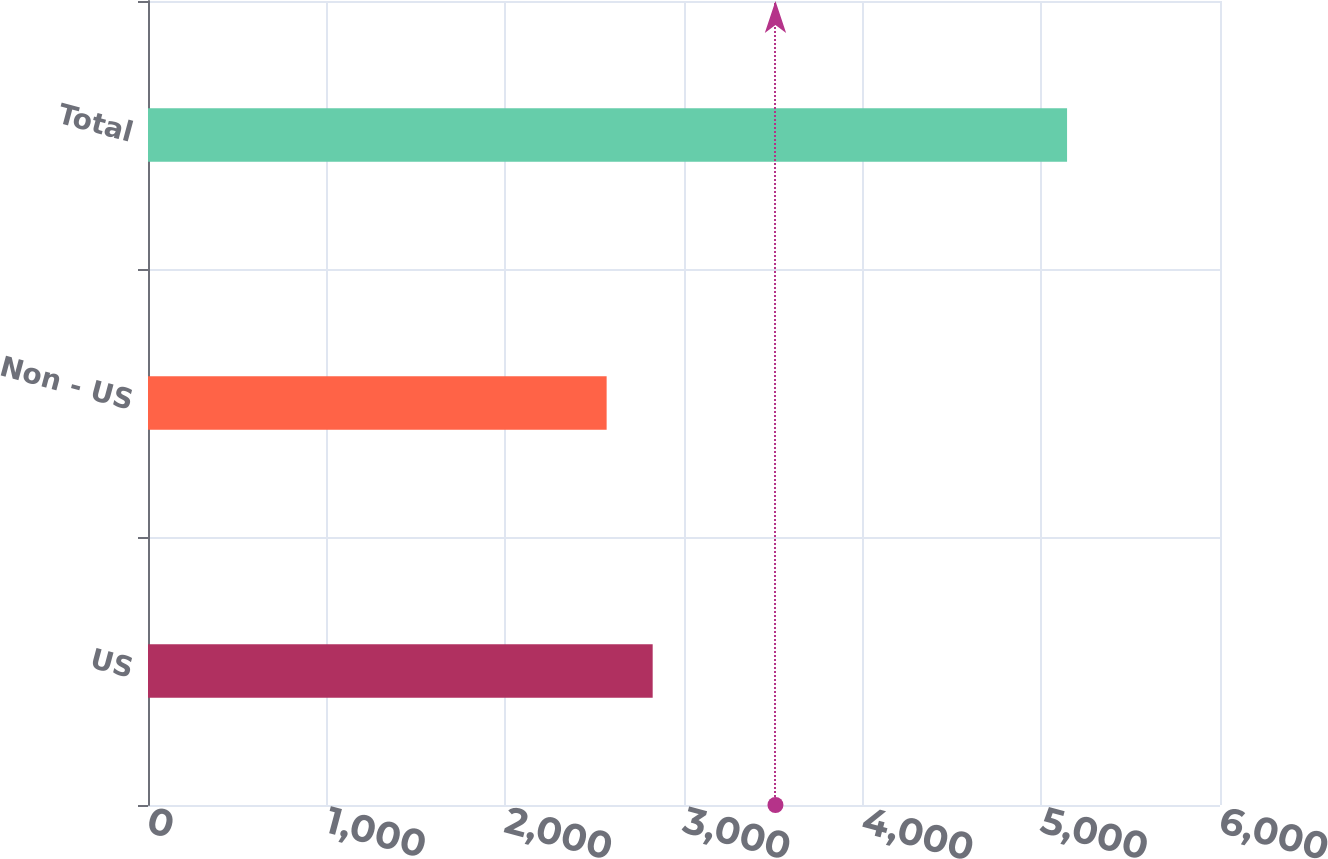<chart> <loc_0><loc_0><loc_500><loc_500><bar_chart><fcel>US<fcel>Non - US<fcel>Total<nl><fcel>2824.7<fcel>2567<fcel>5144<nl></chart> 